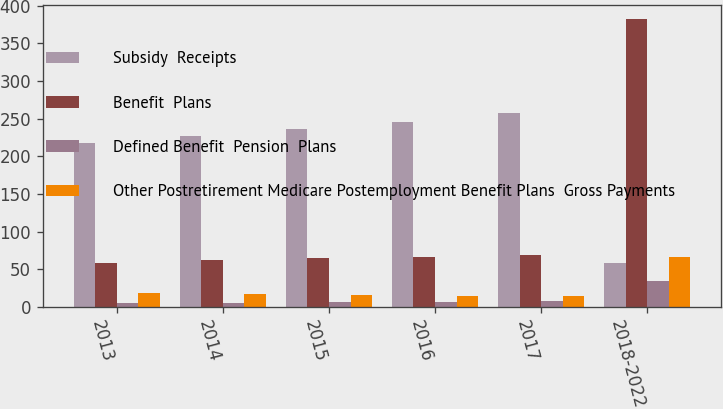Convert chart to OTSL. <chart><loc_0><loc_0><loc_500><loc_500><stacked_bar_chart><ecel><fcel>2013<fcel>2014<fcel>2015<fcel>2016<fcel>2017<fcel>2018-2022<nl><fcel>Subsidy  Receipts<fcel>217.5<fcel>226.5<fcel>236<fcel>245.8<fcel>256.9<fcel>58.6<nl><fcel>Benefit  Plans<fcel>58.6<fcel>62.1<fcel>64.6<fcel>66.2<fcel>68.9<fcel>382.2<nl><fcel>Defined Benefit  Pension  Plans<fcel>5.3<fcel>5.8<fcel>6.3<fcel>6.9<fcel>7.5<fcel>34.5<nl><fcel>Other Postretirement Medicare Postemployment Benefit Plans  Gross Payments<fcel>19.3<fcel>17.6<fcel>16.3<fcel>15.3<fcel>14.6<fcel>66.7<nl></chart> 